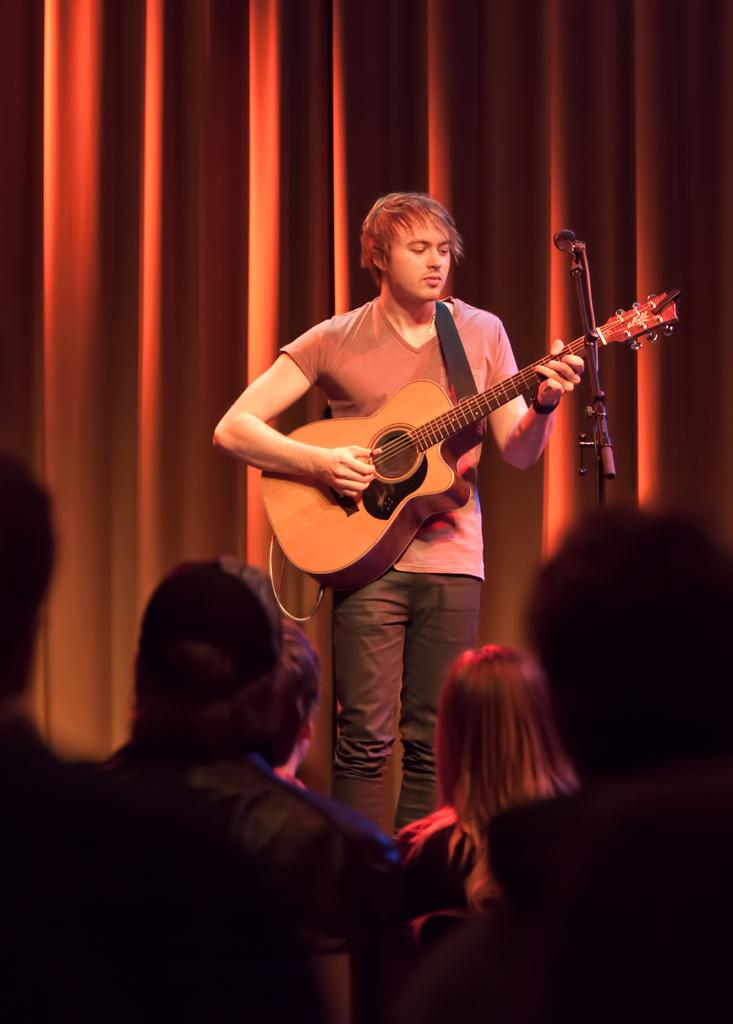Who is the main subject in the image? There is a man standing at the center of the image. What is the man holding in his hand? The man is holding a guitar in his hand. What object is in front of the man? There is a microphone in front of the man. What are the other people in the image doing? There is a group of people sitting and watching the man. What type of crate is being used to store the peace in the image? There is no crate or peace present in the image. 